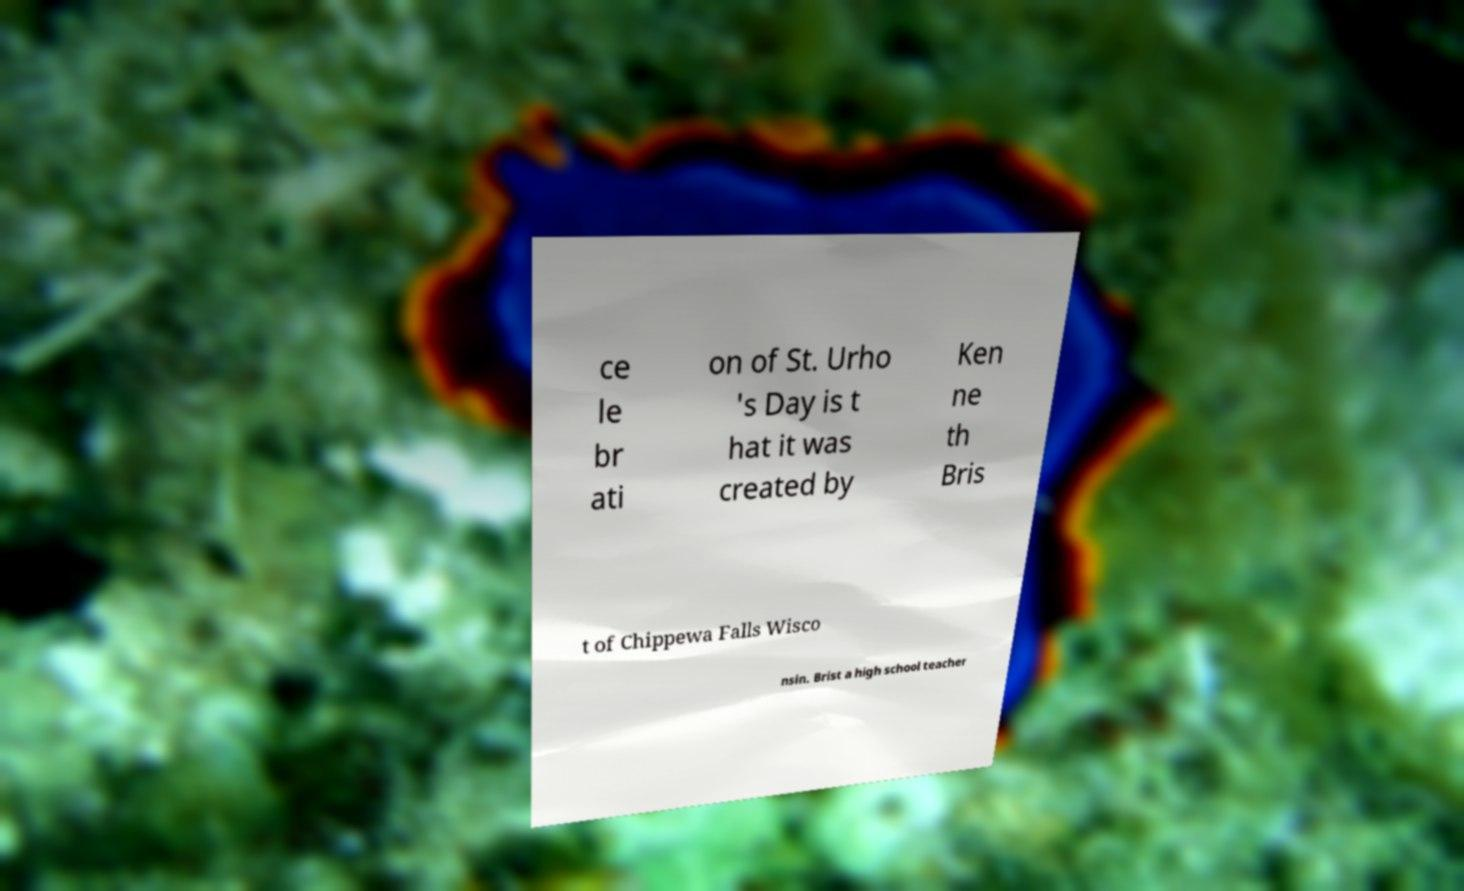What messages or text are displayed in this image? I need them in a readable, typed format. ce le br ati on of St. Urho 's Day is t hat it was created by Ken ne th Bris t of Chippewa Falls Wisco nsin. Brist a high school teacher 